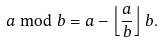Convert formula to latex. <formula><loc_0><loc_0><loc_500><loc_500>a \bmod b = a - \left \lfloor \frac { a } { b } \right \rfloor b .</formula> 